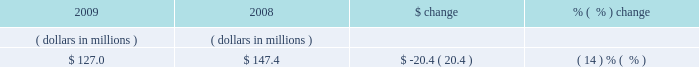Cash provided by operating activities cash provided by operations is dependent primarily upon the payment terms of our license agreements .
To be classified as upfront revenue , we require that 75% ( 75 % ) of a term or perpetual license fee be paid within the first year .
Conversely , payment terms for tsls are generally extended and the license fee is typically paid either quarterly or annually in even increments over the term of the license .
Accordingly , we generally receive cash from upfront license revenue much sooner than from time-based licenses revenue .
Fiscal 2008 to fiscal 2009 .
Cash from operating activities decreased primarily as a result of a decrease in deferred revenue due to the timing of billings and cash payments from certain customers , increased payments to vendors compared to fiscal 2008 and a tax prepayment for an irs settlement .
See note 9 of notes to consolidated financial statements .
Fiscal 2007 to fiscal 2008 .
Cash from operating activities decreased primarily due to the timing of billings and cash payments from customers compared to fiscal 2007 , delivering lower cash inflows during fiscal 2008 and also as a result of a litigation settlement of $ 12.5 million received from magma during fiscal 2007 .
Cash used in investing activities fiscal 2008 to fiscal 2009 .
The decrease in cash used primarily relates to a decrease in our purchases of marketable securities and cash paid for acquisitions as compared to fiscal 2008 , offset by the timing of maturities of marketable securities .
Fiscal 2007 to fiscal 2008 .
The decrease in cash used primarily relates to the sale of marketable securities for our acquisition of synplicity , and as a result of lower capital expenditures during fiscal 2008 as compared to fiscal 2007 .
Cash provided by ( used in ) financing activities fiscal 2008 to fiscal 2009 .
The increase in cash provided primarily relates to the absence of common stock repurchases in fiscal 2009 offset by a decrease in the number of options exercised by employees compared to fiscal 2008 .
Fiscal 2007 to fiscal 2008 .
The increase in cash used primarily relates to more common stock repurchases under our stock repurchase program and options exercised by employees compared to fiscal 2007 .
See note 7 of notes to consolidated financial statements for details of our stock repurchase program .
We hold our cash , cash equivalents and short-term investments in the united states and in foreign accounts , primarily in ireland , bermuda , and japan .
As of october 31 , 2009 , we held an aggregate of $ 612.4 million in cash , cash equivalents and short-term investments in the united states and an aggregate of $ 555.9 million in foreign accounts .
Funds in foreign accounts are generated from revenue outside north america .
At present , such foreign funds are considered to be indefinitely reinvested in foreign countries to the extent of indefinitely reinvested foreign earnings as described in note 9 of notes to consolidated financial statements .
We expect cash provided by operating activities to fluctuate in future periods as a result of a number of factors , including the timing of our billings and collections , our operating results , the timing and amount of tax and other liability payments and cash used in any future acquisitions .
Accounts receivable , net october 31 .

What percentage of cash , cash equivalents and short-term investments was held in foreign accounts as of october 31 , 2009? 
Computations: (555.9 / (612.4 + 555.9))
Answer: 0.47582. 